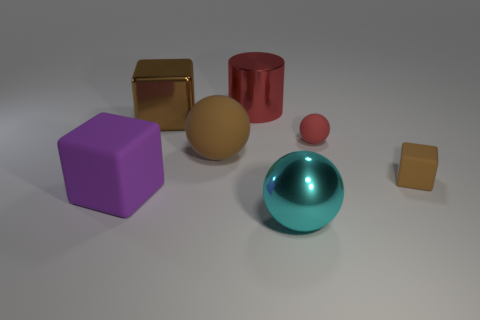Add 3 yellow matte spheres. How many objects exist? 10 Subtract all balls. How many objects are left? 4 Subtract all small cyan metal objects. Subtract all big red objects. How many objects are left? 6 Add 5 large brown matte spheres. How many large brown matte spheres are left? 6 Add 6 small green rubber cylinders. How many small green rubber cylinders exist? 6 Subtract 1 cyan balls. How many objects are left? 6 